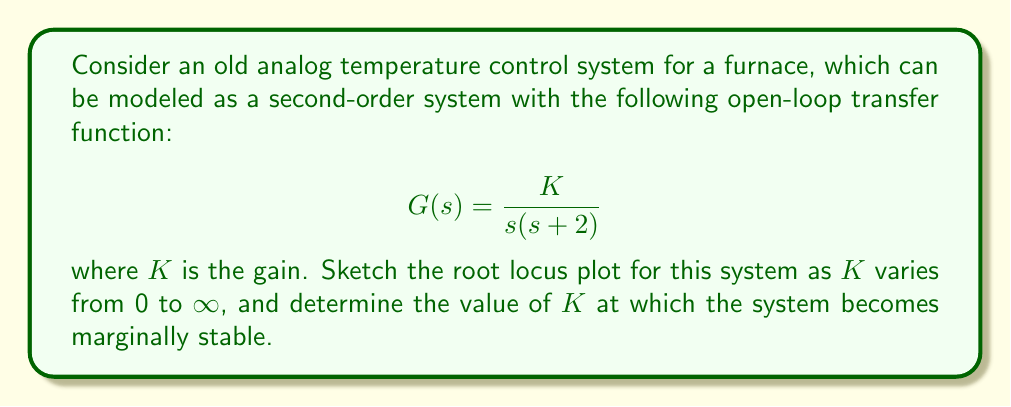Help me with this question. To analyze the root locus plot and find the value of $K$ for marginal stability, we'll follow these steps:

1) First, identify the open-loop poles and zeros:
   Poles: $s = 0$ and $s = -2$
   Zeros: None

2) The root locus will start at the open-loop poles and end at infinity.

3) Determine the asymptotes:
   Number of finite poles (n) = 2
   Number of finite zeros (m) = 0
   Number of asymptotes = n - m = 2

   Angle of asymptotes: $\theta = \frac{(2k+1)\pi}{n-m}$ for $k = 0, 1$
   $\theta_1 = \pm 90°$

   Centroid: $\sigma = \frac{\sum\text{poles} - \sum\text{zeros}}{n-m} = \frac{-2}{2} = -1$

4) Find the break-away point:
   $s^2 + 2s + K = 0$
   $\frac{dK}{ds} = 2s + 2 = 0$
   $s = -1$

5) Find the imaginary axis crossing:
   Use the Routh-Hurwitz criterion:
   $s^2 + 2s + K = 0$
   
   Routh array:
   $$\begin{array}{c|c}
   s^2 & 1 & K \\
   s^1 & 2 & 0 \\
   s^0 & K & 0
   \end{array}$$

   For marginal stability, the first column should have a zero:
   $K = 4$

6) Sketch the root locus:
   - Starts at $s = 0$ and $s = -2$
   - Breaks away at $s = -1$
   - Crosses imaginary axis at $s = \pm j\sqrt{K} = \pm j2$ when $K = 4$
   - Approaches asymptotes at $\pm 90°$ as $K \to \infty$

[asy]
import graph;
size(200);
real xmin=-3, xmax=1, ymin=-3, ymax=3;
draw((xmin,0)--(xmax,0),Arrow);
draw((0,ymin)--(0,ymax),Arrow);
label("Re", (xmax,0), E);
label("Im", (0,ymax), N);

draw((-2,0)--(0,0), blue);
draw((0,0)--(0,2), blue);
draw((0,2)--(0,-2), blue);
draw((0,-2)--(-1,-1), blue);
draw((-1,-1)--(-1,1), blue);
draw((-1,1)--(0,2), blue);

dot((-2,0));
dot((0,0));
dot((-1,0));
dot((0,2));
dot((0,-2));

label("$s=-2$", (-2,0), SW);
label("$s=0$", (0,0), SE);
label("$s=-1$", (-1,0), S);
label("$s=2j$", (0,2), E);
label("$s=-2j$", (0,-2), E);
[/asy]

The system becomes marginally stable when $K = 4$, as this is when the root locus crosses the imaginary axis.
Answer: The value of $K$ at which the system becomes marginally stable is 4. 